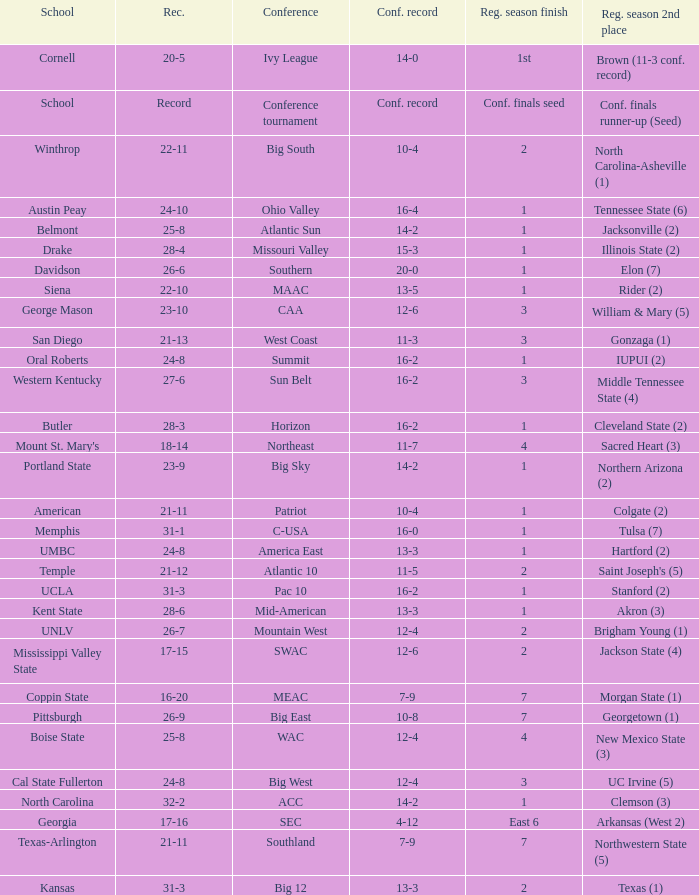What was the overall record of UMBC? 24-8. 